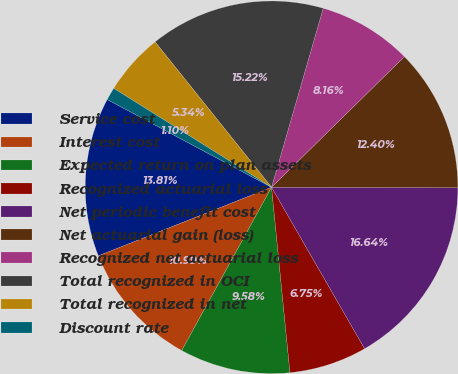<chart> <loc_0><loc_0><loc_500><loc_500><pie_chart><fcel>Service cost<fcel>Interest cost<fcel>Expected return on plan assets<fcel>Recognized actuarial loss<fcel>Net periodic benefit cost<fcel>Net actuarial gain (loss)<fcel>Recognized net actuarial loss<fcel>Total recognized in OCI<fcel>Total recognized in net<fcel>Discount rate<nl><fcel>13.81%<fcel>10.99%<fcel>9.58%<fcel>6.75%<fcel>16.64%<fcel>12.4%<fcel>8.16%<fcel>15.22%<fcel>5.34%<fcel>1.1%<nl></chart> 